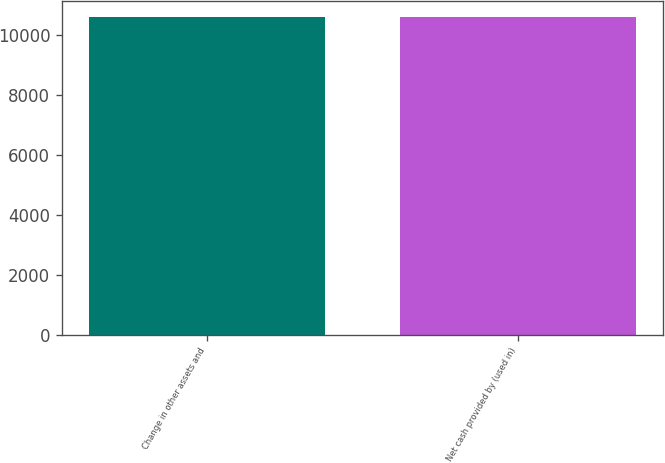<chart> <loc_0><loc_0><loc_500><loc_500><bar_chart><fcel>Change in other assets and<fcel>Net cash provided by (used in)<nl><fcel>10595<fcel>10595.2<nl></chart> 